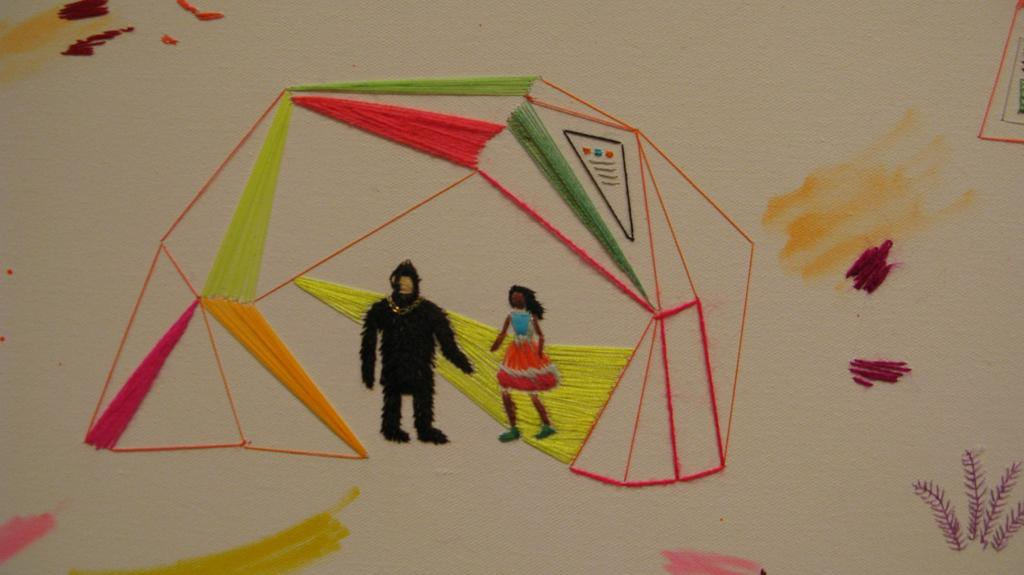What is the main subject of the image? The main subject of the image is an art piece. Can you describe the art piece in the image? The art piece is made with threads on a cloth. How does the art piece join the carriage in the image? There is no carriage present in the image, and therefore the art piece cannot join it. 